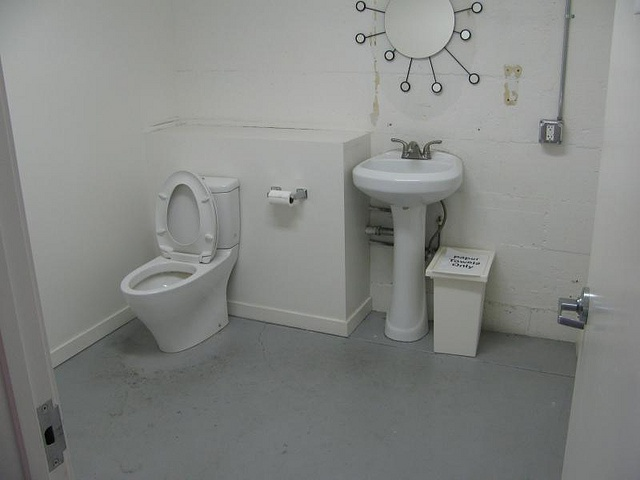Describe the objects in this image and their specific colors. I can see toilet in gray and darkgray tones and sink in gray and darkgray tones in this image. 